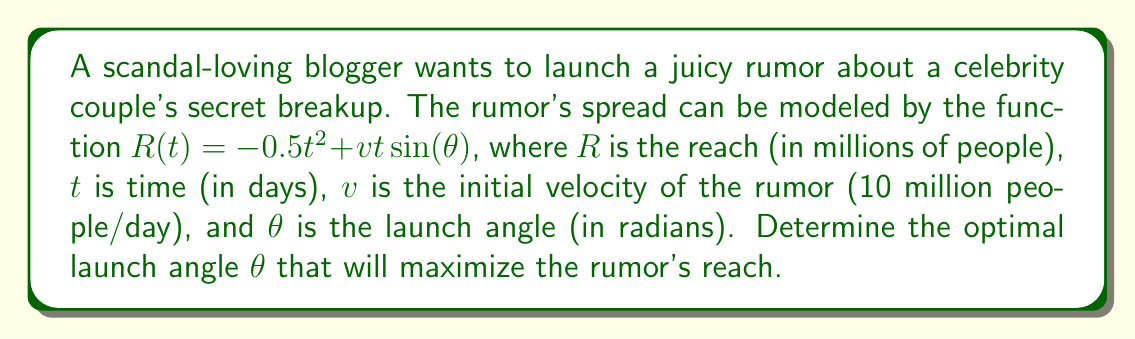Teach me how to tackle this problem. To find the optimal launch angle, we need to maximize the reach function $R(t)$. Here's how we can approach this:

1) First, we need to find the time $t_{max}$ when the reach is at its maximum. We can do this by differentiating $R(t)$ with respect to $t$ and setting it to zero:

   $$\frac{dR}{dt} = -t + v\sin(\theta) = 0$$

   Solving for $t$:
   $$t_{max} = v\sin(\theta)$$

2) Now, we can substitute this $t_{max}$ back into our original function to get the maximum reach in terms of $\theta$:

   $$R_{max}(\theta) = -0.5(v\sin(\theta))^2 + v(v\sin(\theta))\sin(\theta)$$
   $$= -0.5v^2\sin^2(\theta) + v^2\sin^2(\theta)$$
   $$= 0.5v^2\sin^2(\theta)$$

3) To maximize this function, we differentiate with respect to $\theta$ and set it to zero:

   $$\frac{dR_{max}}{d\theta} = v^2\sin(\theta)\cos(\theta) = 0$$

4) This equation is satisfied when $\sin(\theta) = 0$ or $\cos(\theta) = 0$. However, $\sin(\theta) = 0$ would give us a minimum (no reach), so we want $\cos(\theta) = 0$.

5) $\cos(\theta) = 0$ when $\theta = \frac{\pi}{2}$ or $\frac{3\pi}{2}$. Since we're launching upwards, we choose $\theta = \frac{\pi}{2}$.

6) To confirm this is a maximum, we can check the second derivative:

   $$\frac{d^2R_{max}}{d\theta^2} = v^2(\cos^2(\theta) - \sin^2(\theta))$$

   At $\theta = \frac{\pi}{2}$, this equals $-v^2 < 0$, confirming a maximum.

Therefore, the optimal launch angle is $\frac{\pi}{2}$ radians, or 90 degrees.
Answer: The optimal launch angle $\theta$ to maximize the rumor's reach is $\frac{\pi}{2}$ radians or 90 degrees. 